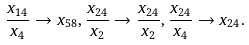<formula> <loc_0><loc_0><loc_500><loc_500>\frac { x _ { 1 4 } } { x _ { 4 } } \rightarrow x _ { 5 8 } , \frac { x _ { 2 4 } } { x _ { 2 } } \rightarrow \frac { x _ { 2 4 } } { x _ { 2 } } , \frac { x _ { 2 4 } } { x _ { 4 } } \rightarrow x _ { 2 4 } .</formula> 